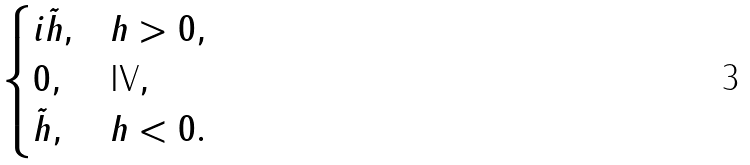<formula> <loc_0><loc_0><loc_500><loc_500>\begin{cases} i \tilde { h } , & h > 0 , \\ 0 , & \text {IV} , \\ \tilde { h } , & h < 0 . \end{cases}</formula> 